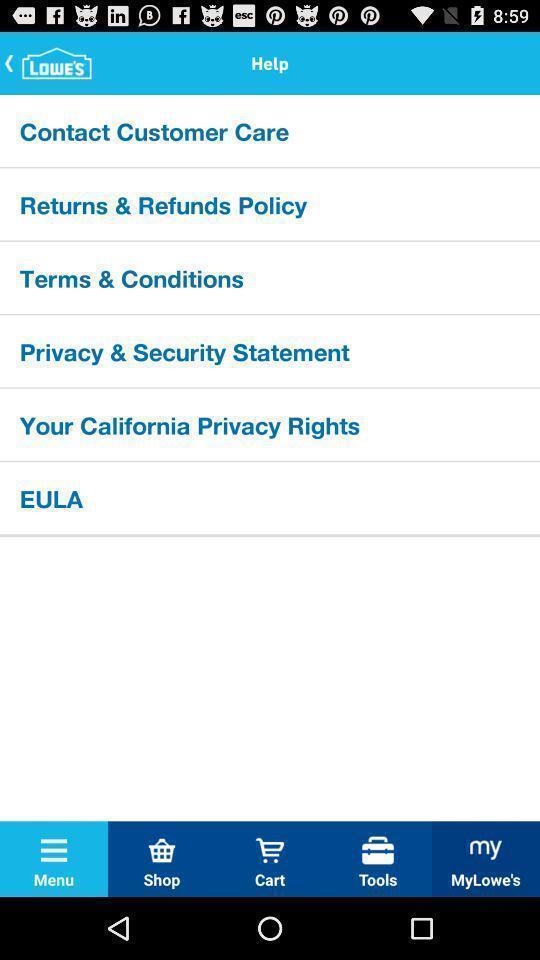Explain the elements present in this screenshot. Screen shows help details in a shopping app. 